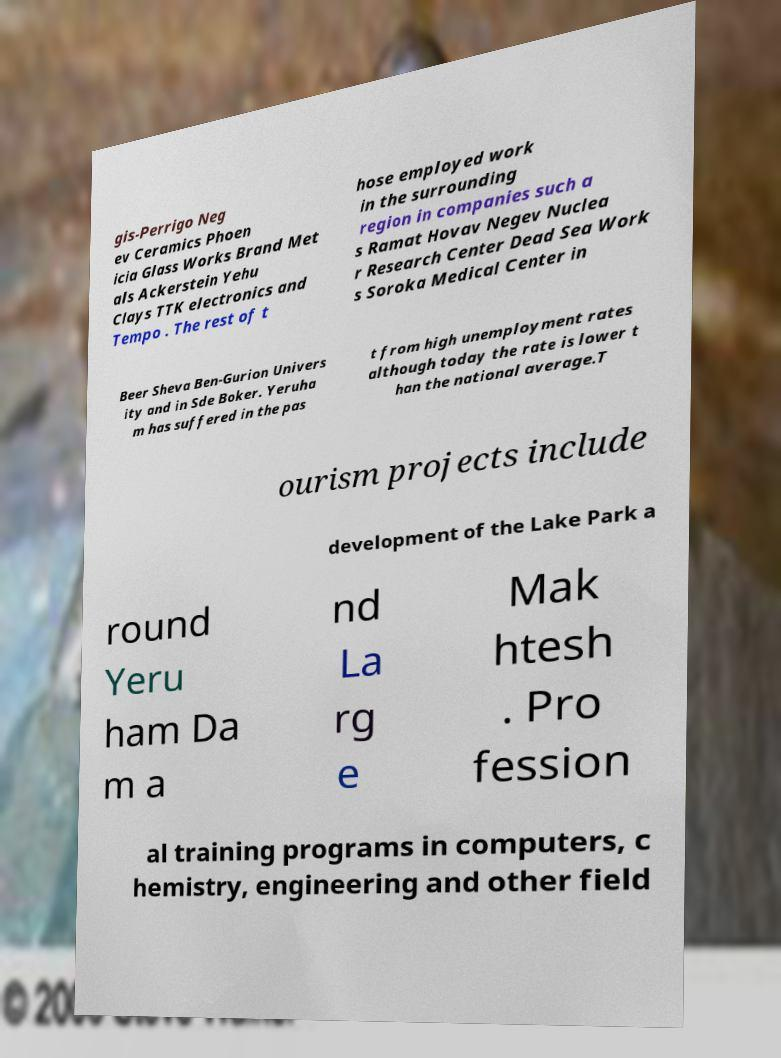Please read and relay the text visible in this image. What does it say? gis-Perrigo Neg ev Ceramics Phoen icia Glass Works Brand Met als Ackerstein Yehu Clays TTK electronics and Tempo . The rest of t hose employed work in the surrounding region in companies such a s Ramat Hovav Negev Nuclea r Research Center Dead Sea Work s Soroka Medical Center in Beer Sheva Ben-Gurion Univers ity and in Sde Boker. Yeruha m has suffered in the pas t from high unemployment rates although today the rate is lower t han the national average.T ourism projects include development of the Lake Park a round Yeru ham Da m a nd La rg e Mak htesh . Pro fession al training programs in computers, c hemistry, engineering and other field 